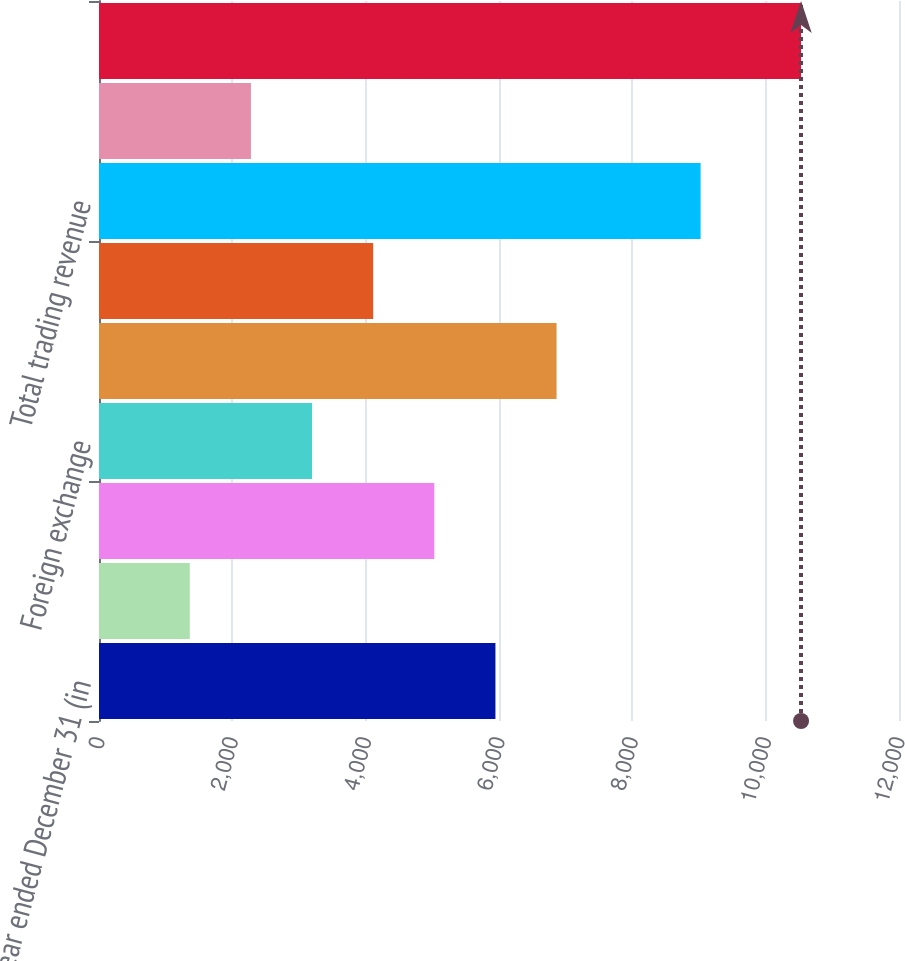Convert chart to OTSL. <chart><loc_0><loc_0><loc_500><loc_500><bar_chart><fcel>Year ended December 31 (in<fcel>Interest rate<fcel>Credit<fcel>Foreign exchange<fcel>Equity<fcel>Commodity<fcel>Total trading revenue<fcel>Private equity gains (a)<fcel>Principal transactions<nl><fcel>5946.5<fcel>1362<fcel>5029.6<fcel>3195.8<fcel>6863.4<fcel>4112.7<fcel>9024<fcel>2278.9<fcel>10531<nl></chart> 